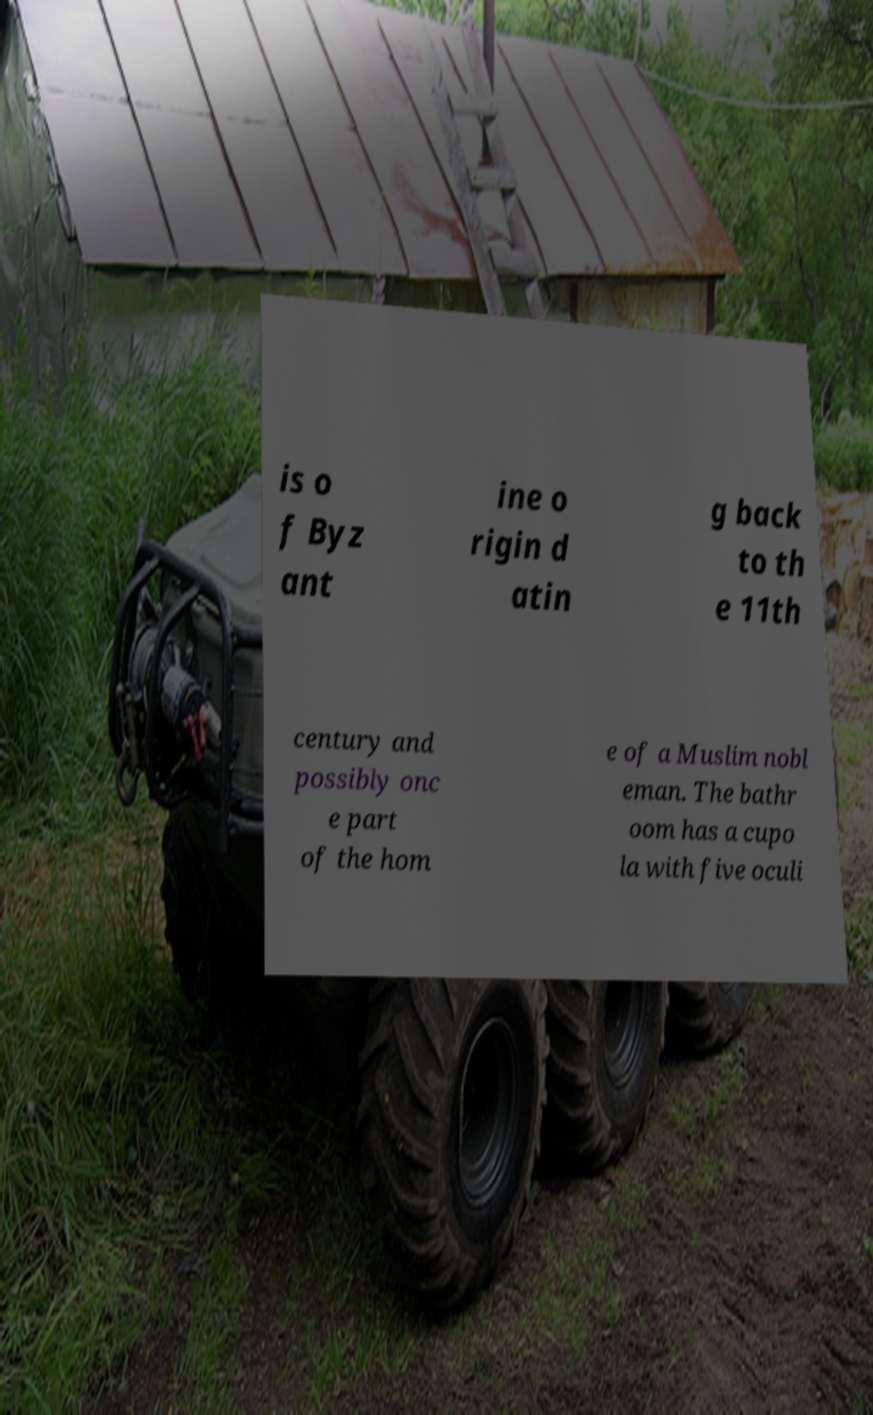Could you extract and type out the text from this image? is o f Byz ant ine o rigin d atin g back to th e 11th century and possibly onc e part of the hom e of a Muslim nobl eman. The bathr oom has a cupo la with five oculi 